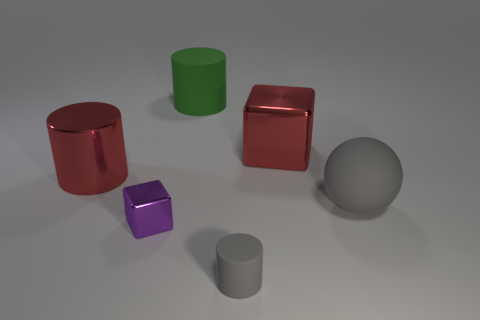Subtract all big red metal cylinders. How many cylinders are left? 2 Subtract 1 cylinders. How many cylinders are left? 2 Add 4 tiny green matte objects. How many objects exist? 10 Subtract all spheres. How many objects are left? 5 Subtract all brown cylinders. Subtract all brown blocks. How many cylinders are left? 3 Add 5 big red metal cylinders. How many big red metal cylinders are left? 6 Add 2 small gray objects. How many small gray objects exist? 3 Subtract 1 gray balls. How many objects are left? 5 Subtract all large green rubber cylinders. Subtract all red metal cylinders. How many objects are left? 4 